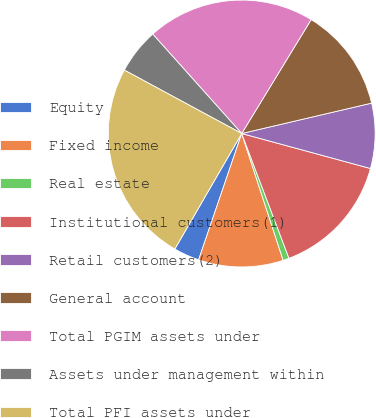Convert chart. <chart><loc_0><loc_0><loc_500><loc_500><pie_chart><fcel>Equity<fcel>Fixed income<fcel>Real estate<fcel>Institutional customers(1)<fcel>Retail customers(2)<fcel>General account<fcel>Total PGIM assets under<fcel>Assets under management within<fcel>Total PFI assets under<nl><fcel>3.12%<fcel>10.26%<fcel>0.74%<fcel>15.01%<fcel>7.88%<fcel>12.63%<fcel>20.33%<fcel>5.5%<fcel>24.53%<nl></chart> 